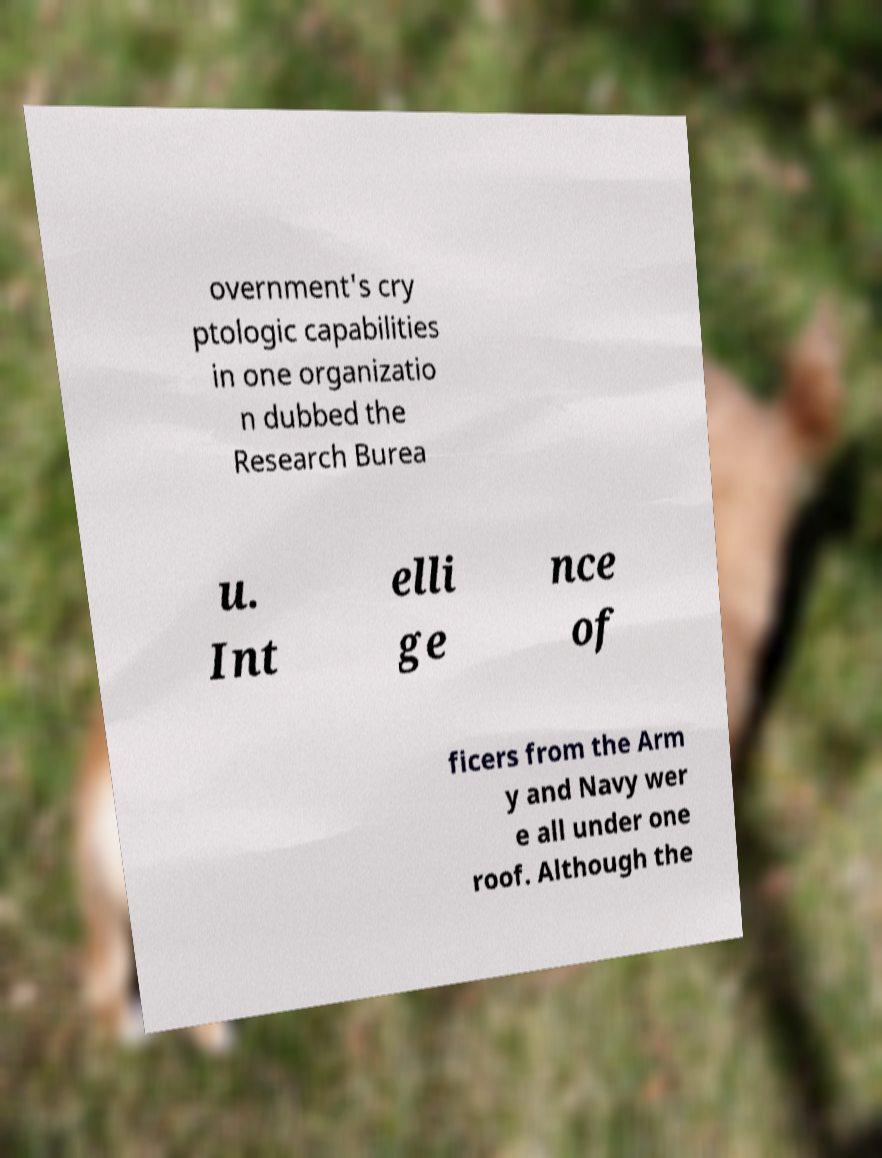Could you extract and type out the text from this image? overnment's cry ptologic capabilities in one organizatio n dubbed the Research Burea u. Int elli ge nce of ficers from the Arm y and Navy wer e all under one roof. Although the 